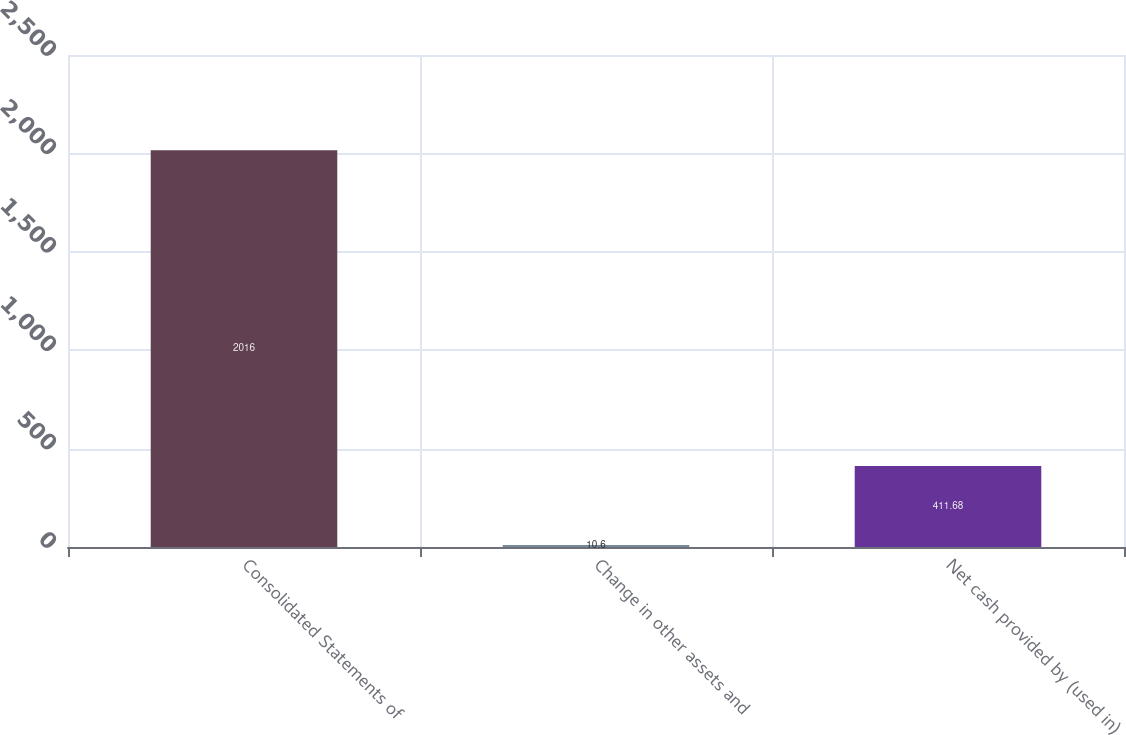Convert chart to OTSL. <chart><loc_0><loc_0><loc_500><loc_500><bar_chart><fcel>Consolidated Statements of<fcel>Change in other assets and<fcel>Net cash provided by (used in)<nl><fcel>2016<fcel>10.6<fcel>411.68<nl></chart> 